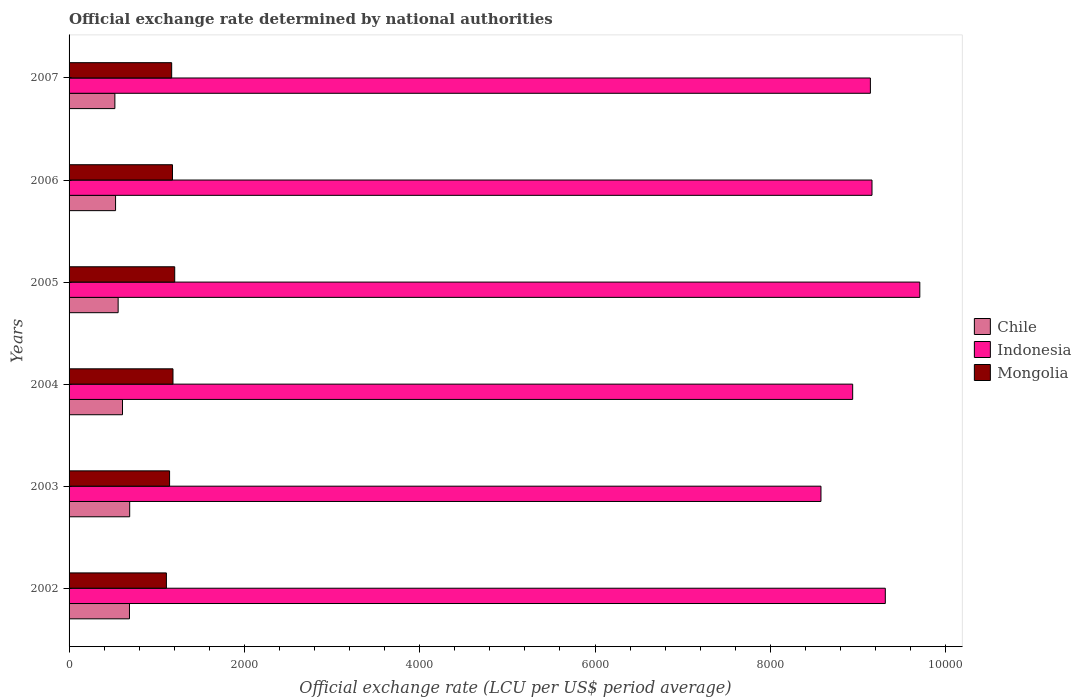How many different coloured bars are there?
Provide a succinct answer. 3. Are the number of bars per tick equal to the number of legend labels?
Your answer should be very brief. Yes. Are the number of bars on each tick of the Y-axis equal?
Offer a terse response. Yes. What is the label of the 5th group of bars from the top?
Offer a very short reply. 2003. In how many cases, is the number of bars for a given year not equal to the number of legend labels?
Your response must be concise. 0. What is the official exchange rate in Indonesia in 2006?
Offer a terse response. 9159.32. Across all years, what is the maximum official exchange rate in Chile?
Keep it short and to the point. 691.4. Across all years, what is the minimum official exchange rate in Indonesia?
Give a very brief answer. 8577.13. What is the total official exchange rate in Indonesia in the graph?
Offer a very short reply. 5.48e+04. What is the difference between the official exchange rate in Chile in 2002 and that in 2004?
Keep it short and to the point. 79.41. What is the difference between the official exchange rate in Indonesia in 2003 and the official exchange rate in Chile in 2002?
Give a very brief answer. 7888.2. What is the average official exchange rate in Chile per year?
Your answer should be very brief. 600.4. In the year 2006, what is the difference between the official exchange rate in Chile and official exchange rate in Mongolia?
Keep it short and to the point. -649.42. In how many years, is the official exchange rate in Mongolia greater than 2000 LCU?
Provide a succinct answer. 0. What is the ratio of the official exchange rate in Mongolia in 2003 to that in 2005?
Make the answer very short. 0.95. What is the difference between the highest and the second highest official exchange rate in Chile?
Make the answer very short. 2.46. What is the difference between the highest and the lowest official exchange rate in Chile?
Provide a succinct answer. 168.93. What does the 1st bar from the top in 2004 represents?
Provide a succinct answer. Mongolia. What does the 3rd bar from the bottom in 2003 represents?
Your answer should be compact. Mongolia. How many years are there in the graph?
Offer a very short reply. 6. What is the difference between two consecutive major ticks on the X-axis?
Ensure brevity in your answer.  2000. How are the legend labels stacked?
Offer a very short reply. Vertical. What is the title of the graph?
Your answer should be very brief. Official exchange rate determined by national authorities. Does "Armenia" appear as one of the legend labels in the graph?
Give a very brief answer. No. What is the label or title of the X-axis?
Your answer should be very brief. Official exchange rate (LCU per US$ period average). What is the Official exchange rate (LCU per US$ period average) of Chile in 2002?
Offer a very short reply. 688.94. What is the Official exchange rate (LCU per US$ period average) in Indonesia in 2002?
Provide a succinct answer. 9311.19. What is the Official exchange rate (LCU per US$ period average) in Mongolia in 2002?
Give a very brief answer. 1110.31. What is the Official exchange rate (LCU per US$ period average) in Chile in 2003?
Provide a succinct answer. 691.4. What is the Official exchange rate (LCU per US$ period average) of Indonesia in 2003?
Your answer should be compact. 8577.13. What is the Official exchange rate (LCU per US$ period average) of Mongolia in 2003?
Your answer should be compact. 1146.54. What is the Official exchange rate (LCU per US$ period average) of Chile in 2004?
Make the answer very short. 609.53. What is the Official exchange rate (LCU per US$ period average) of Indonesia in 2004?
Your answer should be very brief. 8938.85. What is the Official exchange rate (LCU per US$ period average) in Mongolia in 2004?
Your answer should be compact. 1185.3. What is the Official exchange rate (LCU per US$ period average) of Chile in 2005?
Your answer should be compact. 559.77. What is the Official exchange rate (LCU per US$ period average) in Indonesia in 2005?
Keep it short and to the point. 9704.74. What is the Official exchange rate (LCU per US$ period average) of Mongolia in 2005?
Your answer should be very brief. 1205.25. What is the Official exchange rate (LCU per US$ period average) in Chile in 2006?
Give a very brief answer. 530.27. What is the Official exchange rate (LCU per US$ period average) in Indonesia in 2006?
Offer a terse response. 9159.32. What is the Official exchange rate (LCU per US$ period average) of Mongolia in 2006?
Ensure brevity in your answer.  1179.7. What is the Official exchange rate (LCU per US$ period average) in Chile in 2007?
Ensure brevity in your answer.  522.46. What is the Official exchange rate (LCU per US$ period average) of Indonesia in 2007?
Offer a very short reply. 9141. What is the Official exchange rate (LCU per US$ period average) of Mongolia in 2007?
Provide a short and direct response. 1170.4. Across all years, what is the maximum Official exchange rate (LCU per US$ period average) in Chile?
Ensure brevity in your answer.  691.4. Across all years, what is the maximum Official exchange rate (LCU per US$ period average) of Indonesia?
Offer a very short reply. 9704.74. Across all years, what is the maximum Official exchange rate (LCU per US$ period average) in Mongolia?
Keep it short and to the point. 1205.25. Across all years, what is the minimum Official exchange rate (LCU per US$ period average) of Chile?
Your answer should be compact. 522.46. Across all years, what is the minimum Official exchange rate (LCU per US$ period average) of Indonesia?
Your answer should be very brief. 8577.13. Across all years, what is the minimum Official exchange rate (LCU per US$ period average) in Mongolia?
Provide a succinct answer. 1110.31. What is the total Official exchange rate (LCU per US$ period average) of Chile in the graph?
Your answer should be very brief. 3602.37. What is the total Official exchange rate (LCU per US$ period average) of Indonesia in the graph?
Provide a succinct answer. 5.48e+04. What is the total Official exchange rate (LCU per US$ period average) of Mongolia in the graph?
Your response must be concise. 6997.5. What is the difference between the Official exchange rate (LCU per US$ period average) of Chile in 2002 and that in 2003?
Your answer should be compact. -2.46. What is the difference between the Official exchange rate (LCU per US$ period average) in Indonesia in 2002 and that in 2003?
Your answer should be compact. 734.06. What is the difference between the Official exchange rate (LCU per US$ period average) of Mongolia in 2002 and that in 2003?
Offer a terse response. -36.23. What is the difference between the Official exchange rate (LCU per US$ period average) of Chile in 2002 and that in 2004?
Offer a terse response. 79.41. What is the difference between the Official exchange rate (LCU per US$ period average) of Indonesia in 2002 and that in 2004?
Your response must be concise. 372.34. What is the difference between the Official exchange rate (LCU per US$ period average) of Mongolia in 2002 and that in 2004?
Your answer should be very brief. -74.99. What is the difference between the Official exchange rate (LCU per US$ period average) of Chile in 2002 and that in 2005?
Make the answer very short. 129.17. What is the difference between the Official exchange rate (LCU per US$ period average) of Indonesia in 2002 and that in 2005?
Your answer should be compact. -393.55. What is the difference between the Official exchange rate (LCU per US$ period average) of Mongolia in 2002 and that in 2005?
Ensure brevity in your answer.  -94.94. What is the difference between the Official exchange rate (LCU per US$ period average) of Chile in 2002 and that in 2006?
Give a very brief answer. 158.66. What is the difference between the Official exchange rate (LCU per US$ period average) of Indonesia in 2002 and that in 2006?
Your answer should be very brief. 151.88. What is the difference between the Official exchange rate (LCU per US$ period average) in Mongolia in 2002 and that in 2006?
Keep it short and to the point. -69.39. What is the difference between the Official exchange rate (LCU per US$ period average) in Chile in 2002 and that in 2007?
Keep it short and to the point. 166.47. What is the difference between the Official exchange rate (LCU per US$ period average) in Indonesia in 2002 and that in 2007?
Offer a terse response. 170.19. What is the difference between the Official exchange rate (LCU per US$ period average) in Mongolia in 2002 and that in 2007?
Make the answer very short. -60.09. What is the difference between the Official exchange rate (LCU per US$ period average) in Chile in 2003 and that in 2004?
Keep it short and to the point. 81.87. What is the difference between the Official exchange rate (LCU per US$ period average) of Indonesia in 2003 and that in 2004?
Your answer should be compact. -361.72. What is the difference between the Official exchange rate (LCU per US$ period average) of Mongolia in 2003 and that in 2004?
Give a very brief answer. -38.76. What is the difference between the Official exchange rate (LCU per US$ period average) of Chile in 2003 and that in 2005?
Give a very brief answer. 131.63. What is the difference between the Official exchange rate (LCU per US$ period average) in Indonesia in 2003 and that in 2005?
Give a very brief answer. -1127.61. What is the difference between the Official exchange rate (LCU per US$ period average) in Mongolia in 2003 and that in 2005?
Provide a short and direct response. -58.7. What is the difference between the Official exchange rate (LCU per US$ period average) in Chile in 2003 and that in 2006?
Ensure brevity in your answer.  161.12. What is the difference between the Official exchange rate (LCU per US$ period average) of Indonesia in 2003 and that in 2006?
Give a very brief answer. -582.18. What is the difference between the Official exchange rate (LCU per US$ period average) of Mongolia in 2003 and that in 2006?
Provide a short and direct response. -33.16. What is the difference between the Official exchange rate (LCU per US$ period average) of Chile in 2003 and that in 2007?
Keep it short and to the point. 168.93. What is the difference between the Official exchange rate (LCU per US$ period average) of Indonesia in 2003 and that in 2007?
Give a very brief answer. -563.87. What is the difference between the Official exchange rate (LCU per US$ period average) in Mongolia in 2003 and that in 2007?
Ensure brevity in your answer.  -23.86. What is the difference between the Official exchange rate (LCU per US$ period average) in Chile in 2004 and that in 2005?
Ensure brevity in your answer.  49.76. What is the difference between the Official exchange rate (LCU per US$ period average) of Indonesia in 2004 and that in 2005?
Your response must be concise. -765.89. What is the difference between the Official exchange rate (LCU per US$ period average) in Mongolia in 2004 and that in 2005?
Ensure brevity in your answer.  -19.95. What is the difference between the Official exchange rate (LCU per US$ period average) of Chile in 2004 and that in 2006?
Provide a short and direct response. 79.25. What is the difference between the Official exchange rate (LCU per US$ period average) of Indonesia in 2004 and that in 2006?
Your answer should be very brief. -220.47. What is the difference between the Official exchange rate (LCU per US$ period average) of Mongolia in 2004 and that in 2006?
Provide a short and direct response. 5.6. What is the difference between the Official exchange rate (LCU per US$ period average) of Chile in 2004 and that in 2007?
Keep it short and to the point. 87.06. What is the difference between the Official exchange rate (LCU per US$ period average) of Indonesia in 2004 and that in 2007?
Your answer should be compact. -202.15. What is the difference between the Official exchange rate (LCU per US$ period average) in Mongolia in 2004 and that in 2007?
Keep it short and to the point. 14.9. What is the difference between the Official exchange rate (LCU per US$ period average) in Chile in 2005 and that in 2006?
Your answer should be very brief. 29.49. What is the difference between the Official exchange rate (LCU per US$ period average) of Indonesia in 2005 and that in 2006?
Keep it short and to the point. 545.42. What is the difference between the Official exchange rate (LCU per US$ period average) of Mongolia in 2005 and that in 2006?
Your answer should be compact. 25.55. What is the difference between the Official exchange rate (LCU per US$ period average) of Chile in 2005 and that in 2007?
Provide a succinct answer. 37.3. What is the difference between the Official exchange rate (LCU per US$ period average) of Indonesia in 2005 and that in 2007?
Your answer should be compact. 563.74. What is the difference between the Official exchange rate (LCU per US$ period average) in Mongolia in 2005 and that in 2007?
Provide a succinct answer. 34.85. What is the difference between the Official exchange rate (LCU per US$ period average) in Chile in 2006 and that in 2007?
Give a very brief answer. 7.81. What is the difference between the Official exchange rate (LCU per US$ period average) of Indonesia in 2006 and that in 2007?
Your response must be concise. 18.32. What is the difference between the Official exchange rate (LCU per US$ period average) in Mongolia in 2006 and that in 2007?
Offer a very short reply. 9.3. What is the difference between the Official exchange rate (LCU per US$ period average) in Chile in 2002 and the Official exchange rate (LCU per US$ period average) in Indonesia in 2003?
Your answer should be compact. -7888.2. What is the difference between the Official exchange rate (LCU per US$ period average) in Chile in 2002 and the Official exchange rate (LCU per US$ period average) in Mongolia in 2003?
Offer a very short reply. -457.61. What is the difference between the Official exchange rate (LCU per US$ period average) in Indonesia in 2002 and the Official exchange rate (LCU per US$ period average) in Mongolia in 2003?
Provide a short and direct response. 8164.65. What is the difference between the Official exchange rate (LCU per US$ period average) in Chile in 2002 and the Official exchange rate (LCU per US$ period average) in Indonesia in 2004?
Give a very brief answer. -8249.91. What is the difference between the Official exchange rate (LCU per US$ period average) in Chile in 2002 and the Official exchange rate (LCU per US$ period average) in Mongolia in 2004?
Offer a terse response. -496.36. What is the difference between the Official exchange rate (LCU per US$ period average) of Indonesia in 2002 and the Official exchange rate (LCU per US$ period average) of Mongolia in 2004?
Give a very brief answer. 8125.89. What is the difference between the Official exchange rate (LCU per US$ period average) in Chile in 2002 and the Official exchange rate (LCU per US$ period average) in Indonesia in 2005?
Your answer should be compact. -9015.81. What is the difference between the Official exchange rate (LCU per US$ period average) in Chile in 2002 and the Official exchange rate (LCU per US$ period average) in Mongolia in 2005?
Your answer should be compact. -516.31. What is the difference between the Official exchange rate (LCU per US$ period average) in Indonesia in 2002 and the Official exchange rate (LCU per US$ period average) in Mongolia in 2005?
Your answer should be very brief. 8105.94. What is the difference between the Official exchange rate (LCU per US$ period average) of Chile in 2002 and the Official exchange rate (LCU per US$ period average) of Indonesia in 2006?
Your response must be concise. -8470.38. What is the difference between the Official exchange rate (LCU per US$ period average) of Chile in 2002 and the Official exchange rate (LCU per US$ period average) of Mongolia in 2006?
Provide a short and direct response. -490.76. What is the difference between the Official exchange rate (LCU per US$ period average) of Indonesia in 2002 and the Official exchange rate (LCU per US$ period average) of Mongolia in 2006?
Ensure brevity in your answer.  8131.49. What is the difference between the Official exchange rate (LCU per US$ period average) of Chile in 2002 and the Official exchange rate (LCU per US$ period average) of Indonesia in 2007?
Your answer should be very brief. -8452.06. What is the difference between the Official exchange rate (LCU per US$ period average) of Chile in 2002 and the Official exchange rate (LCU per US$ period average) of Mongolia in 2007?
Your answer should be compact. -481.46. What is the difference between the Official exchange rate (LCU per US$ period average) in Indonesia in 2002 and the Official exchange rate (LCU per US$ period average) in Mongolia in 2007?
Your answer should be very brief. 8140.79. What is the difference between the Official exchange rate (LCU per US$ period average) of Chile in 2003 and the Official exchange rate (LCU per US$ period average) of Indonesia in 2004?
Ensure brevity in your answer.  -8247.45. What is the difference between the Official exchange rate (LCU per US$ period average) in Chile in 2003 and the Official exchange rate (LCU per US$ period average) in Mongolia in 2004?
Give a very brief answer. -493.9. What is the difference between the Official exchange rate (LCU per US$ period average) in Indonesia in 2003 and the Official exchange rate (LCU per US$ period average) in Mongolia in 2004?
Keep it short and to the point. 7391.84. What is the difference between the Official exchange rate (LCU per US$ period average) in Chile in 2003 and the Official exchange rate (LCU per US$ period average) in Indonesia in 2005?
Make the answer very short. -9013.34. What is the difference between the Official exchange rate (LCU per US$ period average) of Chile in 2003 and the Official exchange rate (LCU per US$ period average) of Mongolia in 2005?
Give a very brief answer. -513.85. What is the difference between the Official exchange rate (LCU per US$ period average) in Indonesia in 2003 and the Official exchange rate (LCU per US$ period average) in Mongolia in 2005?
Give a very brief answer. 7371.89. What is the difference between the Official exchange rate (LCU per US$ period average) of Chile in 2003 and the Official exchange rate (LCU per US$ period average) of Indonesia in 2006?
Offer a very short reply. -8467.92. What is the difference between the Official exchange rate (LCU per US$ period average) of Chile in 2003 and the Official exchange rate (LCU per US$ period average) of Mongolia in 2006?
Give a very brief answer. -488.3. What is the difference between the Official exchange rate (LCU per US$ period average) of Indonesia in 2003 and the Official exchange rate (LCU per US$ period average) of Mongolia in 2006?
Offer a very short reply. 7397.43. What is the difference between the Official exchange rate (LCU per US$ period average) of Chile in 2003 and the Official exchange rate (LCU per US$ period average) of Indonesia in 2007?
Your answer should be very brief. -8449.6. What is the difference between the Official exchange rate (LCU per US$ period average) of Chile in 2003 and the Official exchange rate (LCU per US$ period average) of Mongolia in 2007?
Ensure brevity in your answer.  -479. What is the difference between the Official exchange rate (LCU per US$ period average) in Indonesia in 2003 and the Official exchange rate (LCU per US$ period average) in Mongolia in 2007?
Give a very brief answer. 7406.73. What is the difference between the Official exchange rate (LCU per US$ period average) in Chile in 2004 and the Official exchange rate (LCU per US$ period average) in Indonesia in 2005?
Ensure brevity in your answer.  -9095.21. What is the difference between the Official exchange rate (LCU per US$ period average) of Chile in 2004 and the Official exchange rate (LCU per US$ period average) of Mongolia in 2005?
Ensure brevity in your answer.  -595.72. What is the difference between the Official exchange rate (LCU per US$ period average) in Indonesia in 2004 and the Official exchange rate (LCU per US$ period average) in Mongolia in 2005?
Your answer should be very brief. 7733.6. What is the difference between the Official exchange rate (LCU per US$ period average) in Chile in 2004 and the Official exchange rate (LCU per US$ period average) in Indonesia in 2006?
Provide a succinct answer. -8549.79. What is the difference between the Official exchange rate (LCU per US$ period average) in Chile in 2004 and the Official exchange rate (LCU per US$ period average) in Mongolia in 2006?
Offer a terse response. -570.17. What is the difference between the Official exchange rate (LCU per US$ period average) in Indonesia in 2004 and the Official exchange rate (LCU per US$ period average) in Mongolia in 2006?
Your response must be concise. 7759.15. What is the difference between the Official exchange rate (LCU per US$ period average) of Chile in 2004 and the Official exchange rate (LCU per US$ period average) of Indonesia in 2007?
Your answer should be very brief. -8531.47. What is the difference between the Official exchange rate (LCU per US$ period average) of Chile in 2004 and the Official exchange rate (LCU per US$ period average) of Mongolia in 2007?
Keep it short and to the point. -560.87. What is the difference between the Official exchange rate (LCU per US$ period average) of Indonesia in 2004 and the Official exchange rate (LCU per US$ period average) of Mongolia in 2007?
Offer a very short reply. 7768.45. What is the difference between the Official exchange rate (LCU per US$ period average) in Chile in 2005 and the Official exchange rate (LCU per US$ period average) in Indonesia in 2006?
Make the answer very short. -8599.55. What is the difference between the Official exchange rate (LCU per US$ period average) in Chile in 2005 and the Official exchange rate (LCU per US$ period average) in Mongolia in 2006?
Keep it short and to the point. -619.93. What is the difference between the Official exchange rate (LCU per US$ period average) of Indonesia in 2005 and the Official exchange rate (LCU per US$ period average) of Mongolia in 2006?
Provide a succinct answer. 8525.04. What is the difference between the Official exchange rate (LCU per US$ period average) of Chile in 2005 and the Official exchange rate (LCU per US$ period average) of Indonesia in 2007?
Provide a short and direct response. -8581.23. What is the difference between the Official exchange rate (LCU per US$ period average) in Chile in 2005 and the Official exchange rate (LCU per US$ period average) in Mongolia in 2007?
Provide a short and direct response. -610.63. What is the difference between the Official exchange rate (LCU per US$ period average) of Indonesia in 2005 and the Official exchange rate (LCU per US$ period average) of Mongolia in 2007?
Keep it short and to the point. 8534.34. What is the difference between the Official exchange rate (LCU per US$ period average) in Chile in 2006 and the Official exchange rate (LCU per US$ period average) in Indonesia in 2007?
Offer a terse response. -8610.73. What is the difference between the Official exchange rate (LCU per US$ period average) in Chile in 2006 and the Official exchange rate (LCU per US$ period average) in Mongolia in 2007?
Give a very brief answer. -640.13. What is the difference between the Official exchange rate (LCU per US$ period average) of Indonesia in 2006 and the Official exchange rate (LCU per US$ period average) of Mongolia in 2007?
Give a very brief answer. 7988.92. What is the average Official exchange rate (LCU per US$ period average) in Chile per year?
Give a very brief answer. 600.39. What is the average Official exchange rate (LCU per US$ period average) of Indonesia per year?
Offer a terse response. 9138.71. What is the average Official exchange rate (LCU per US$ period average) of Mongolia per year?
Your response must be concise. 1166.25. In the year 2002, what is the difference between the Official exchange rate (LCU per US$ period average) in Chile and Official exchange rate (LCU per US$ period average) in Indonesia?
Provide a short and direct response. -8622.25. In the year 2002, what is the difference between the Official exchange rate (LCU per US$ period average) in Chile and Official exchange rate (LCU per US$ period average) in Mongolia?
Provide a succinct answer. -421.37. In the year 2002, what is the difference between the Official exchange rate (LCU per US$ period average) in Indonesia and Official exchange rate (LCU per US$ period average) in Mongolia?
Offer a very short reply. 8200.88. In the year 2003, what is the difference between the Official exchange rate (LCU per US$ period average) of Chile and Official exchange rate (LCU per US$ period average) of Indonesia?
Offer a terse response. -7885.74. In the year 2003, what is the difference between the Official exchange rate (LCU per US$ period average) of Chile and Official exchange rate (LCU per US$ period average) of Mongolia?
Your response must be concise. -455.14. In the year 2003, what is the difference between the Official exchange rate (LCU per US$ period average) in Indonesia and Official exchange rate (LCU per US$ period average) in Mongolia?
Your response must be concise. 7430.59. In the year 2004, what is the difference between the Official exchange rate (LCU per US$ period average) in Chile and Official exchange rate (LCU per US$ period average) in Indonesia?
Offer a very short reply. -8329.32. In the year 2004, what is the difference between the Official exchange rate (LCU per US$ period average) of Chile and Official exchange rate (LCU per US$ period average) of Mongolia?
Ensure brevity in your answer.  -575.77. In the year 2004, what is the difference between the Official exchange rate (LCU per US$ period average) in Indonesia and Official exchange rate (LCU per US$ period average) in Mongolia?
Make the answer very short. 7753.55. In the year 2005, what is the difference between the Official exchange rate (LCU per US$ period average) of Chile and Official exchange rate (LCU per US$ period average) of Indonesia?
Your answer should be very brief. -9144.97. In the year 2005, what is the difference between the Official exchange rate (LCU per US$ period average) in Chile and Official exchange rate (LCU per US$ period average) in Mongolia?
Offer a very short reply. -645.48. In the year 2005, what is the difference between the Official exchange rate (LCU per US$ period average) of Indonesia and Official exchange rate (LCU per US$ period average) of Mongolia?
Provide a succinct answer. 8499.5. In the year 2006, what is the difference between the Official exchange rate (LCU per US$ period average) of Chile and Official exchange rate (LCU per US$ period average) of Indonesia?
Your answer should be very brief. -8629.04. In the year 2006, what is the difference between the Official exchange rate (LCU per US$ period average) in Chile and Official exchange rate (LCU per US$ period average) in Mongolia?
Provide a succinct answer. -649.42. In the year 2006, what is the difference between the Official exchange rate (LCU per US$ period average) of Indonesia and Official exchange rate (LCU per US$ period average) of Mongolia?
Ensure brevity in your answer.  7979.62. In the year 2007, what is the difference between the Official exchange rate (LCU per US$ period average) of Chile and Official exchange rate (LCU per US$ period average) of Indonesia?
Keep it short and to the point. -8618.54. In the year 2007, what is the difference between the Official exchange rate (LCU per US$ period average) of Chile and Official exchange rate (LCU per US$ period average) of Mongolia?
Provide a succinct answer. -647.94. In the year 2007, what is the difference between the Official exchange rate (LCU per US$ period average) in Indonesia and Official exchange rate (LCU per US$ period average) in Mongolia?
Your answer should be very brief. 7970.6. What is the ratio of the Official exchange rate (LCU per US$ period average) in Indonesia in 2002 to that in 2003?
Your answer should be compact. 1.09. What is the ratio of the Official exchange rate (LCU per US$ period average) in Mongolia in 2002 to that in 2003?
Provide a short and direct response. 0.97. What is the ratio of the Official exchange rate (LCU per US$ period average) of Chile in 2002 to that in 2004?
Make the answer very short. 1.13. What is the ratio of the Official exchange rate (LCU per US$ period average) of Indonesia in 2002 to that in 2004?
Keep it short and to the point. 1.04. What is the ratio of the Official exchange rate (LCU per US$ period average) of Mongolia in 2002 to that in 2004?
Offer a very short reply. 0.94. What is the ratio of the Official exchange rate (LCU per US$ period average) of Chile in 2002 to that in 2005?
Make the answer very short. 1.23. What is the ratio of the Official exchange rate (LCU per US$ period average) of Indonesia in 2002 to that in 2005?
Your answer should be compact. 0.96. What is the ratio of the Official exchange rate (LCU per US$ period average) in Mongolia in 2002 to that in 2005?
Ensure brevity in your answer.  0.92. What is the ratio of the Official exchange rate (LCU per US$ period average) of Chile in 2002 to that in 2006?
Offer a terse response. 1.3. What is the ratio of the Official exchange rate (LCU per US$ period average) in Indonesia in 2002 to that in 2006?
Ensure brevity in your answer.  1.02. What is the ratio of the Official exchange rate (LCU per US$ period average) in Chile in 2002 to that in 2007?
Your answer should be very brief. 1.32. What is the ratio of the Official exchange rate (LCU per US$ period average) in Indonesia in 2002 to that in 2007?
Offer a terse response. 1.02. What is the ratio of the Official exchange rate (LCU per US$ period average) in Mongolia in 2002 to that in 2007?
Give a very brief answer. 0.95. What is the ratio of the Official exchange rate (LCU per US$ period average) of Chile in 2003 to that in 2004?
Keep it short and to the point. 1.13. What is the ratio of the Official exchange rate (LCU per US$ period average) in Indonesia in 2003 to that in 2004?
Your answer should be very brief. 0.96. What is the ratio of the Official exchange rate (LCU per US$ period average) in Mongolia in 2003 to that in 2004?
Offer a terse response. 0.97. What is the ratio of the Official exchange rate (LCU per US$ period average) of Chile in 2003 to that in 2005?
Provide a succinct answer. 1.24. What is the ratio of the Official exchange rate (LCU per US$ period average) of Indonesia in 2003 to that in 2005?
Give a very brief answer. 0.88. What is the ratio of the Official exchange rate (LCU per US$ period average) of Mongolia in 2003 to that in 2005?
Offer a very short reply. 0.95. What is the ratio of the Official exchange rate (LCU per US$ period average) of Chile in 2003 to that in 2006?
Your answer should be very brief. 1.3. What is the ratio of the Official exchange rate (LCU per US$ period average) of Indonesia in 2003 to that in 2006?
Provide a short and direct response. 0.94. What is the ratio of the Official exchange rate (LCU per US$ period average) in Mongolia in 2003 to that in 2006?
Keep it short and to the point. 0.97. What is the ratio of the Official exchange rate (LCU per US$ period average) of Chile in 2003 to that in 2007?
Offer a terse response. 1.32. What is the ratio of the Official exchange rate (LCU per US$ period average) of Indonesia in 2003 to that in 2007?
Your answer should be compact. 0.94. What is the ratio of the Official exchange rate (LCU per US$ period average) in Mongolia in 2003 to that in 2007?
Ensure brevity in your answer.  0.98. What is the ratio of the Official exchange rate (LCU per US$ period average) of Chile in 2004 to that in 2005?
Ensure brevity in your answer.  1.09. What is the ratio of the Official exchange rate (LCU per US$ period average) of Indonesia in 2004 to that in 2005?
Provide a short and direct response. 0.92. What is the ratio of the Official exchange rate (LCU per US$ period average) in Mongolia in 2004 to that in 2005?
Keep it short and to the point. 0.98. What is the ratio of the Official exchange rate (LCU per US$ period average) in Chile in 2004 to that in 2006?
Give a very brief answer. 1.15. What is the ratio of the Official exchange rate (LCU per US$ period average) in Indonesia in 2004 to that in 2006?
Ensure brevity in your answer.  0.98. What is the ratio of the Official exchange rate (LCU per US$ period average) in Mongolia in 2004 to that in 2006?
Your response must be concise. 1. What is the ratio of the Official exchange rate (LCU per US$ period average) in Chile in 2004 to that in 2007?
Offer a terse response. 1.17. What is the ratio of the Official exchange rate (LCU per US$ period average) of Indonesia in 2004 to that in 2007?
Your answer should be very brief. 0.98. What is the ratio of the Official exchange rate (LCU per US$ period average) in Mongolia in 2004 to that in 2007?
Offer a terse response. 1.01. What is the ratio of the Official exchange rate (LCU per US$ period average) of Chile in 2005 to that in 2006?
Your response must be concise. 1.06. What is the ratio of the Official exchange rate (LCU per US$ period average) of Indonesia in 2005 to that in 2006?
Your answer should be compact. 1.06. What is the ratio of the Official exchange rate (LCU per US$ period average) of Mongolia in 2005 to that in 2006?
Offer a terse response. 1.02. What is the ratio of the Official exchange rate (LCU per US$ period average) of Chile in 2005 to that in 2007?
Offer a terse response. 1.07. What is the ratio of the Official exchange rate (LCU per US$ period average) in Indonesia in 2005 to that in 2007?
Offer a terse response. 1.06. What is the ratio of the Official exchange rate (LCU per US$ period average) in Mongolia in 2005 to that in 2007?
Give a very brief answer. 1.03. What is the ratio of the Official exchange rate (LCU per US$ period average) in Chile in 2006 to that in 2007?
Your response must be concise. 1.01. What is the ratio of the Official exchange rate (LCU per US$ period average) in Mongolia in 2006 to that in 2007?
Offer a very short reply. 1.01. What is the difference between the highest and the second highest Official exchange rate (LCU per US$ period average) in Chile?
Keep it short and to the point. 2.46. What is the difference between the highest and the second highest Official exchange rate (LCU per US$ period average) in Indonesia?
Your answer should be very brief. 393.55. What is the difference between the highest and the second highest Official exchange rate (LCU per US$ period average) of Mongolia?
Offer a very short reply. 19.95. What is the difference between the highest and the lowest Official exchange rate (LCU per US$ period average) of Chile?
Give a very brief answer. 168.93. What is the difference between the highest and the lowest Official exchange rate (LCU per US$ period average) in Indonesia?
Your response must be concise. 1127.61. What is the difference between the highest and the lowest Official exchange rate (LCU per US$ period average) in Mongolia?
Your response must be concise. 94.94. 